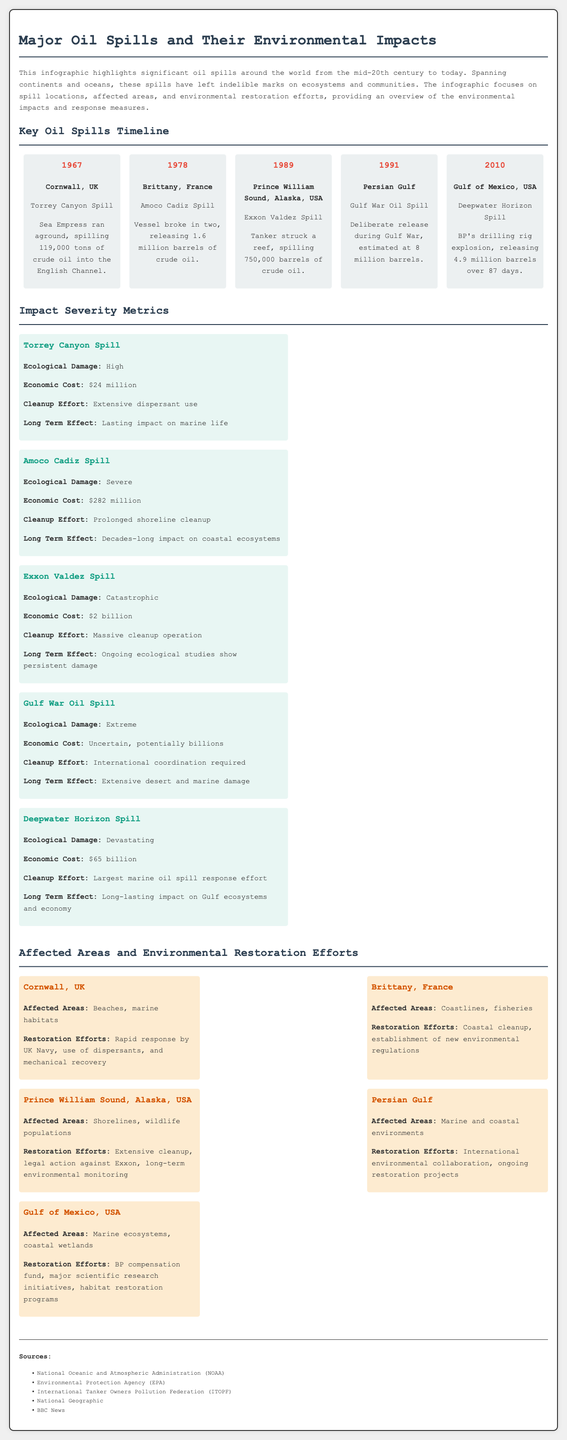what year did the Torrey Canyon spill occur? The year of the Torrey Canyon spill is specified in the timeline section of the document.
Answer: 1967 how many barrels were released in the Amoco Cadiz spill? The amount of oil released during the Amoco Cadiz spill is provided in the timeline detailing the event.
Answer: 1.6 million barrels what was the economic cost of the Exxon Valdez spill? The economic cost of the Exxon Valdez spill is listed in the impact severity metrics section.
Answer: 2 billion which region was affected by the Gulf War Oil Spill? The affected region of the Gulf War Oil Spill is mentioned in the section on affected areas and restoration efforts.
Answer: Persian Gulf what type of cleanup effort was noted for the Deepwater Horizon spill? The type of cleanup effort for the Deepwater Horizon spill is listed in the impact severity metrics.
Answer: Largest marine oil spill response effort which oil spill had the highest estimated ecological damage rating? The ecological damage rating for each spill is compared, with the highest rating noted in the impact severity metrics.
Answer: Exxon Valdez Spill what was a key restoration effort in Cornwall, UK? The restoration efforts in Cornwall, UK concerning the oil spill are highlighted in the affected areas section.
Answer: Rapid response by UK Navy how many oil spills are mentioned in the timeline? The timeline lists significant oil spills, which can be counted to find the total.
Answer: 5 what does the document highlight about the environmental effects of oil spills? The document discusses the long-term impacts on ecosystems and communities after major oil spills.
Answer: Lasting impacts on ecosystems and communities 